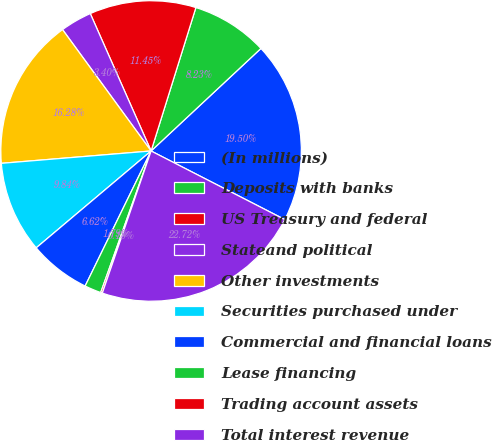Convert chart. <chart><loc_0><loc_0><loc_500><loc_500><pie_chart><fcel>(In millions)<fcel>Deposits with banks<fcel>US Treasury and federal<fcel>Stateand political<fcel>Other investments<fcel>Securities purchased under<fcel>Commercial and financial loans<fcel>Lease financing<fcel>Trading account assets<fcel>Total interest revenue<nl><fcel>19.5%<fcel>8.23%<fcel>11.45%<fcel>3.4%<fcel>16.28%<fcel>9.84%<fcel>6.62%<fcel>1.79%<fcel>0.18%<fcel>22.72%<nl></chart> 